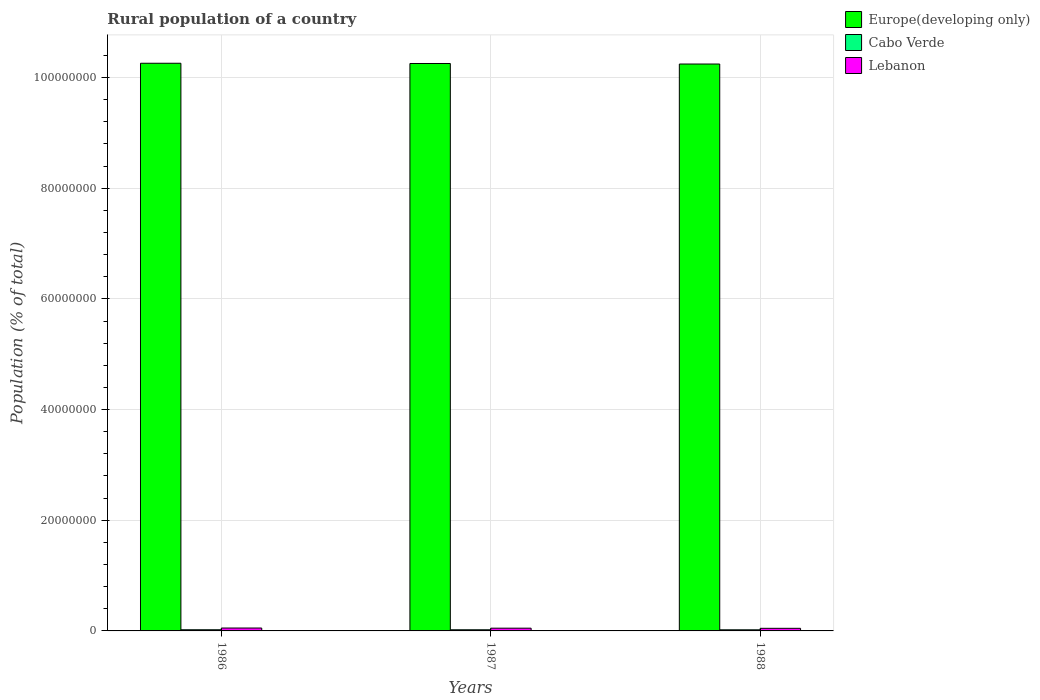Are the number of bars per tick equal to the number of legend labels?
Your response must be concise. Yes. Are the number of bars on each tick of the X-axis equal?
Your response must be concise. Yes. How many bars are there on the 2nd tick from the left?
Offer a terse response. 3. How many bars are there on the 3rd tick from the right?
Ensure brevity in your answer.  3. What is the label of the 2nd group of bars from the left?
Offer a very short reply. 1987. What is the rural population in Europe(developing only) in 1988?
Offer a very short reply. 1.02e+08. Across all years, what is the maximum rural population in Europe(developing only)?
Your answer should be very brief. 1.03e+08. Across all years, what is the minimum rural population in Europe(developing only)?
Your answer should be very brief. 1.02e+08. In which year was the rural population in Cabo Verde maximum?
Provide a short and direct response. 1986. In which year was the rural population in Cabo Verde minimum?
Offer a terse response. 1988. What is the total rural population in Europe(developing only) in the graph?
Make the answer very short. 3.08e+08. What is the difference between the rural population in Europe(developing only) in 1986 and that in 1987?
Give a very brief answer. 4.12e+04. What is the difference between the rural population in Cabo Verde in 1986 and the rural population in Europe(developing only) in 1988?
Your answer should be compact. -1.02e+08. What is the average rural population in Europe(developing only) per year?
Your answer should be compact. 1.03e+08. In the year 1986, what is the difference between the rural population in Europe(developing only) and rural population in Lebanon?
Offer a very short reply. 1.02e+08. What is the ratio of the rural population in Cabo Verde in 1986 to that in 1988?
Offer a very short reply. 1.05. Is the rural population in Cabo Verde in 1987 less than that in 1988?
Make the answer very short. No. Is the difference between the rural population in Europe(developing only) in 1986 and 1988 greater than the difference between the rural population in Lebanon in 1986 and 1988?
Make the answer very short. Yes. What is the difference between the highest and the second highest rural population in Europe(developing only)?
Provide a short and direct response. 4.12e+04. What is the difference between the highest and the lowest rural population in Cabo Verde?
Keep it short and to the point. 1.01e+04. What does the 1st bar from the left in 1986 represents?
Give a very brief answer. Europe(developing only). What does the 1st bar from the right in 1987 represents?
Offer a terse response. Lebanon. Is it the case that in every year, the sum of the rural population in Europe(developing only) and rural population in Lebanon is greater than the rural population in Cabo Verde?
Your answer should be compact. Yes. Are all the bars in the graph horizontal?
Offer a terse response. No. How many years are there in the graph?
Provide a short and direct response. 3. What is the difference between two consecutive major ticks on the Y-axis?
Your answer should be compact. 2.00e+07. Does the graph contain any zero values?
Ensure brevity in your answer.  No. How many legend labels are there?
Provide a short and direct response. 3. What is the title of the graph?
Your answer should be very brief. Rural population of a country. What is the label or title of the X-axis?
Keep it short and to the point. Years. What is the label or title of the Y-axis?
Offer a very short reply. Population (% of total). What is the Population (% of total) in Europe(developing only) in 1986?
Ensure brevity in your answer.  1.03e+08. What is the Population (% of total) of Cabo Verde in 1986?
Your answer should be compact. 2.11e+05. What is the Population (% of total) of Lebanon in 1986?
Offer a terse response. 5.23e+05. What is the Population (% of total) in Europe(developing only) in 1987?
Your answer should be compact. 1.03e+08. What is the Population (% of total) in Cabo Verde in 1987?
Give a very brief answer. 2.06e+05. What is the Population (% of total) of Lebanon in 1987?
Keep it short and to the point. 4.96e+05. What is the Population (% of total) of Europe(developing only) in 1988?
Ensure brevity in your answer.  1.02e+08. What is the Population (% of total) in Cabo Verde in 1988?
Your response must be concise. 2.01e+05. What is the Population (% of total) in Lebanon in 1988?
Your response must be concise. 4.70e+05. Across all years, what is the maximum Population (% of total) in Europe(developing only)?
Provide a short and direct response. 1.03e+08. Across all years, what is the maximum Population (% of total) in Cabo Verde?
Your answer should be compact. 2.11e+05. Across all years, what is the maximum Population (% of total) in Lebanon?
Your response must be concise. 5.23e+05. Across all years, what is the minimum Population (% of total) of Europe(developing only)?
Offer a terse response. 1.02e+08. Across all years, what is the minimum Population (% of total) in Cabo Verde?
Your response must be concise. 2.01e+05. Across all years, what is the minimum Population (% of total) in Lebanon?
Ensure brevity in your answer.  4.70e+05. What is the total Population (% of total) in Europe(developing only) in the graph?
Your answer should be very brief. 3.08e+08. What is the total Population (% of total) of Cabo Verde in the graph?
Offer a very short reply. 6.18e+05. What is the total Population (% of total) in Lebanon in the graph?
Provide a short and direct response. 1.49e+06. What is the difference between the Population (% of total) in Europe(developing only) in 1986 and that in 1987?
Your answer should be very brief. 4.12e+04. What is the difference between the Population (% of total) in Cabo Verde in 1986 and that in 1987?
Make the answer very short. 4821. What is the difference between the Population (% of total) in Lebanon in 1986 and that in 1987?
Your answer should be very brief. 2.75e+04. What is the difference between the Population (% of total) of Europe(developing only) in 1986 and that in 1988?
Give a very brief answer. 1.39e+05. What is the difference between the Population (% of total) in Cabo Verde in 1986 and that in 1988?
Your response must be concise. 1.01e+04. What is the difference between the Population (% of total) in Lebanon in 1986 and that in 1988?
Provide a short and direct response. 5.36e+04. What is the difference between the Population (% of total) in Europe(developing only) in 1987 and that in 1988?
Your answer should be compact. 9.74e+04. What is the difference between the Population (% of total) in Cabo Verde in 1987 and that in 1988?
Offer a terse response. 5265. What is the difference between the Population (% of total) in Lebanon in 1987 and that in 1988?
Your response must be concise. 2.61e+04. What is the difference between the Population (% of total) of Europe(developing only) in 1986 and the Population (% of total) of Cabo Verde in 1987?
Keep it short and to the point. 1.02e+08. What is the difference between the Population (% of total) of Europe(developing only) in 1986 and the Population (% of total) of Lebanon in 1987?
Make the answer very short. 1.02e+08. What is the difference between the Population (% of total) of Cabo Verde in 1986 and the Population (% of total) of Lebanon in 1987?
Keep it short and to the point. -2.85e+05. What is the difference between the Population (% of total) in Europe(developing only) in 1986 and the Population (% of total) in Cabo Verde in 1988?
Offer a very short reply. 1.02e+08. What is the difference between the Population (% of total) of Europe(developing only) in 1986 and the Population (% of total) of Lebanon in 1988?
Your response must be concise. 1.02e+08. What is the difference between the Population (% of total) in Cabo Verde in 1986 and the Population (% of total) in Lebanon in 1988?
Your response must be concise. -2.59e+05. What is the difference between the Population (% of total) of Europe(developing only) in 1987 and the Population (% of total) of Cabo Verde in 1988?
Your response must be concise. 1.02e+08. What is the difference between the Population (% of total) in Europe(developing only) in 1987 and the Population (% of total) in Lebanon in 1988?
Your answer should be compact. 1.02e+08. What is the difference between the Population (% of total) in Cabo Verde in 1987 and the Population (% of total) in Lebanon in 1988?
Your answer should be compact. -2.63e+05. What is the average Population (% of total) in Europe(developing only) per year?
Offer a terse response. 1.03e+08. What is the average Population (% of total) in Cabo Verde per year?
Your answer should be compact. 2.06e+05. What is the average Population (% of total) of Lebanon per year?
Make the answer very short. 4.96e+05. In the year 1986, what is the difference between the Population (% of total) in Europe(developing only) and Population (% of total) in Cabo Verde?
Ensure brevity in your answer.  1.02e+08. In the year 1986, what is the difference between the Population (% of total) in Europe(developing only) and Population (% of total) in Lebanon?
Keep it short and to the point. 1.02e+08. In the year 1986, what is the difference between the Population (% of total) of Cabo Verde and Population (% of total) of Lebanon?
Make the answer very short. -3.12e+05. In the year 1987, what is the difference between the Population (% of total) in Europe(developing only) and Population (% of total) in Cabo Verde?
Give a very brief answer. 1.02e+08. In the year 1987, what is the difference between the Population (% of total) in Europe(developing only) and Population (% of total) in Lebanon?
Ensure brevity in your answer.  1.02e+08. In the year 1987, what is the difference between the Population (% of total) of Cabo Verde and Population (% of total) of Lebanon?
Offer a terse response. -2.90e+05. In the year 1988, what is the difference between the Population (% of total) in Europe(developing only) and Population (% of total) in Cabo Verde?
Provide a succinct answer. 1.02e+08. In the year 1988, what is the difference between the Population (% of total) in Europe(developing only) and Population (% of total) in Lebanon?
Make the answer very short. 1.02e+08. In the year 1988, what is the difference between the Population (% of total) in Cabo Verde and Population (% of total) in Lebanon?
Offer a terse response. -2.69e+05. What is the ratio of the Population (% of total) in Europe(developing only) in 1986 to that in 1987?
Ensure brevity in your answer.  1. What is the ratio of the Population (% of total) in Cabo Verde in 1986 to that in 1987?
Make the answer very short. 1.02. What is the ratio of the Population (% of total) of Lebanon in 1986 to that in 1987?
Your response must be concise. 1.06. What is the ratio of the Population (% of total) of Cabo Verde in 1986 to that in 1988?
Provide a succinct answer. 1.05. What is the ratio of the Population (% of total) of Lebanon in 1986 to that in 1988?
Provide a short and direct response. 1.11. What is the ratio of the Population (% of total) in Cabo Verde in 1987 to that in 1988?
Make the answer very short. 1.03. What is the ratio of the Population (% of total) in Lebanon in 1987 to that in 1988?
Provide a short and direct response. 1.06. What is the difference between the highest and the second highest Population (% of total) of Europe(developing only)?
Your response must be concise. 4.12e+04. What is the difference between the highest and the second highest Population (% of total) of Cabo Verde?
Your answer should be very brief. 4821. What is the difference between the highest and the second highest Population (% of total) in Lebanon?
Provide a short and direct response. 2.75e+04. What is the difference between the highest and the lowest Population (% of total) in Europe(developing only)?
Your answer should be compact. 1.39e+05. What is the difference between the highest and the lowest Population (% of total) in Cabo Verde?
Make the answer very short. 1.01e+04. What is the difference between the highest and the lowest Population (% of total) of Lebanon?
Keep it short and to the point. 5.36e+04. 